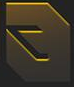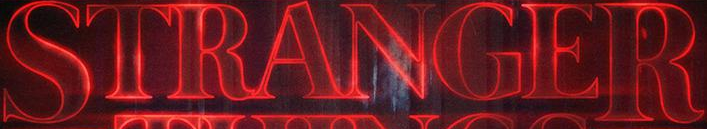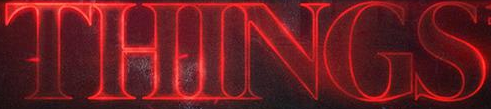Read the text content from these images in order, separated by a semicolon. #; STRANGER; THINGS 